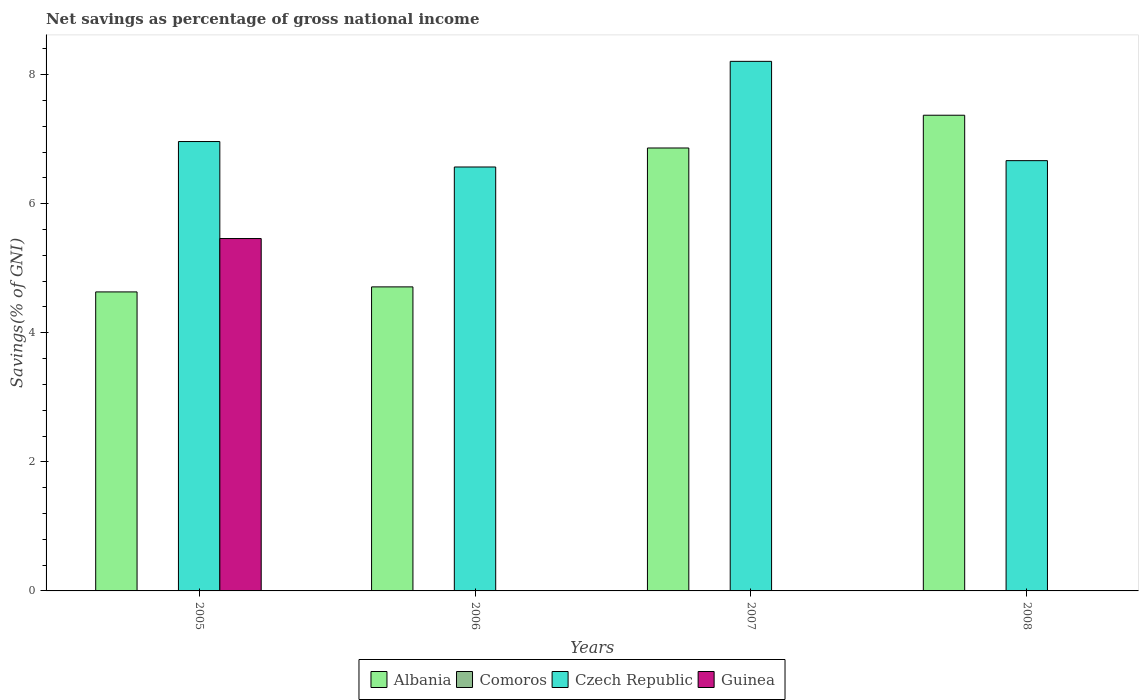Are the number of bars per tick equal to the number of legend labels?
Offer a very short reply. No. How many bars are there on the 4th tick from the left?
Your answer should be very brief. 2. What is the label of the 4th group of bars from the left?
Your answer should be compact. 2008. In how many cases, is the number of bars for a given year not equal to the number of legend labels?
Make the answer very short. 4. What is the total savings in Guinea in 2007?
Provide a succinct answer. 0. Across all years, what is the maximum total savings in Czech Republic?
Provide a succinct answer. 8.21. What is the total total savings in Albania in the graph?
Provide a short and direct response. 23.58. What is the difference between the total savings in Albania in 2005 and that in 2007?
Make the answer very short. -2.23. What is the average total savings in Czech Republic per year?
Your response must be concise. 7.1. In the year 2008, what is the difference between the total savings in Albania and total savings in Czech Republic?
Your response must be concise. 0.7. In how many years, is the total savings in Albania greater than 4 %?
Keep it short and to the point. 4. What is the ratio of the total savings in Albania in 2006 to that in 2007?
Your response must be concise. 0.69. What is the difference between the highest and the second highest total savings in Czech Republic?
Offer a very short reply. 1.24. What is the difference between the highest and the lowest total savings in Albania?
Offer a very short reply. 2.74. In how many years, is the total savings in Czech Republic greater than the average total savings in Czech Republic taken over all years?
Your answer should be very brief. 1. Is the sum of the total savings in Czech Republic in 2007 and 2008 greater than the maximum total savings in Comoros across all years?
Your answer should be very brief. Yes. Is it the case that in every year, the sum of the total savings in Guinea and total savings in Czech Republic is greater than the sum of total savings in Albania and total savings in Comoros?
Your response must be concise. No. How many years are there in the graph?
Give a very brief answer. 4. What is the difference between two consecutive major ticks on the Y-axis?
Provide a short and direct response. 2. Does the graph contain any zero values?
Offer a very short reply. Yes. Does the graph contain grids?
Offer a very short reply. No. Where does the legend appear in the graph?
Ensure brevity in your answer.  Bottom center. How many legend labels are there?
Your response must be concise. 4. What is the title of the graph?
Offer a terse response. Net savings as percentage of gross national income. Does "Iceland" appear as one of the legend labels in the graph?
Provide a succinct answer. No. What is the label or title of the X-axis?
Your answer should be compact. Years. What is the label or title of the Y-axis?
Your answer should be compact. Savings(% of GNI). What is the Savings(% of GNI) of Albania in 2005?
Your answer should be very brief. 4.63. What is the Savings(% of GNI) in Czech Republic in 2005?
Ensure brevity in your answer.  6.96. What is the Savings(% of GNI) of Guinea in 2005?
Your answer should be compact. 5.46. What is the Savings(% of GNI) of Albania in 2006?
Your response must be concise. 4.71. What is the Savings(% of GNI) in Comoros in 2006?
Give a very brief answer. 0. What is the Savings(% of GNI) in Czech Republic in 2006?
Offer a terse response. 6.57. What is the Savings(% of GNI) in Guinea in 2006?
Provide a short and direct response. 0. What is the Savings(% of GNI) of Albania in 2007?
Provide a succinct answer. 6.86. What is the Savings(% of GNI) of Czech Republic in 2007?
Ensure brevity in your answer.  8.21. What is the Savings(% of GNI) in Albania in 2008?
Make the answer very short. 7.37. What is the Savings(% of GNI) of Comoros in 2008?
Offer a very short reply. 0. What is the Savings(% of GNI) in Czech Republic in 2008?
Provide a short and direct response. 6.67. Across all years, what is the maximum Savings(% of GNI) in Albania?
Provide a short and direct response. 7.37. Across all years, what is the maximum Savings(% of GNI) of Czech Republic?
Give a very brief answer. 8.21. Across all years, what is the maximum Savings(% of GNI) in Guinea?
Make the answer very short. 5.46. Across all years, what is the minimum Savings(% of GNI) of Albania?
Give a very brief answer. 4.63. Across all years, what is the minimum Savings(% of GNI) in Czech Republic?
Your answer should be very brief. 6.57. What is the total Savings(% of GNI) of Albania in the graph?
Ensure brevity in your answer.  23.58. What is the total Savings(% of GNI) of Comoros in the graph?
Your response must be concise. 0. What is the total Savings(% of GNI) in Czech Republic in the graph?
Keep it short and to the point. 28.41. What is the total Savings(% of GNI) in Guinea in the graph?
Give a very brief answer. 5.46. What is the difference between the Savings(% of GNI) of Albania in 2005 and that in 2006?
Make the answer very short. -0.08. What is the difference between the Savings(% of GNI) in Czech Republic in 2005 and that in 2006?
Your answer should be very brief. 0.39. What is the difference between the Savings(% of GNI) of Albania in 2005 and that in 2007?
Provide a short and direct response. -2.23. What is the difference between the Savings(% of GNI) in Czech Republic in 2005 and that in 2007?
Provide a succinct answer. -1.24. What is the difference between the Savings(% of GNI) of Albania in 2005 and that in 2008?
Offer a very short reply. -2.74. What is the difference between the Savings(% of GNI) of Czech Republic in 2005 and that in 2008?
Keep it short and to the point. 0.3. What is the difference between the Savings(% of GNI) in Albania in 2006 and that in 2007?
Ensure brevity in your answer.  -2.15. What is the difference between the Savings(% of GNI) of Czech Republic in 2006 and that in 2007?
Give a very brief answer. -1.64. What is the difference between the Savings(% of GNI) of Albania in 2006 and that in 2008?
Provide a succinct answer. -2.66. What is the difference between the Savings(% of GNI) of Czech Republic in 2006 and that in 2008?
Ensure brevity in your answer.  -0.1. What is the difference between the Savings(% of GNI) in Albania in 2007 and that in 2008?
Make the answer very short. -0.51. What is the difference between the Savings(% of GNI) of Czech Republic in 2007 and that in 2008?
Provide a short and direct response. 1.54. What is the difference between the Savings(% of GNI) in Albania in 2005 and the Savings(% of GNI) in Czech Republic in 2006?
Ensure brevity in your answer.  -1.94. What is the difference between the Savings(% of GNI) in Albania in 2005 and the Savings(% of GNI) in Czech Republic in 2007?
Provide a short and direct response. -3.57. What is the difference between the Savings(% of GNI) of Albania in 2005 and the Savings(% of GNI) of Czech Republic in 2008?
Your answer should be very brief. -2.03. What is the difference between the Savings(% of GNI) of Albania in 2006 and the Savings(% of GNI) of Czech Republic in 2007?
Your response must be concise. -3.5. What is the difference between the Savings(% of GNI) in Albania in 2006 and the Savings(% of GNI) in Czech Republic in 2008?
Keep it short and to the point. -1.96. What is the difference between the Savings(% of GNI) in Albania in 2007 and the Savings(% of GNI) in Czech Republic in 2008?
Your answer should be very brief. 0.2. What is the average Savings(% of GNI) in Albania per year?
Your answer should be very brief. 5.9. What is the average Savings(% of GNI) in Czech Republic per year?
Provide a short and direct response. 7.1. What is the average Savings(% of GNI) in Guinea per year?
Make the answer very short. 1.37. In the year 2005, what is the difference between the Savings(% of GNI) of Albania and Savings(% of GNI) of Czech Republic?
Offer a very short reply. -2.33. In the year 2005, what is the difference between the Savings(% of GNI) in Albania and Savings(% of GNI) in Guinea?
Offer a terse response. -0.83. In the year 2005, what is the difference between the Savings(% of GNI) of Czech Republic and Savings(% of GNI) of Guinea?
Your answer should be compact. 1.5. In the year 2006, what is the difference between the Savings(% of GNI) in Albania and Savings(% of GNI) in Czech Republic?
Your answer should be very brief. -1.86. In the year 2007, what is the difference between the Savings(% of GNI) in Albania and Savings(% of GNI) in Czech Republic?
Your answer should be compact. -1.34. In the year 2008, what is the difference between the Savings(% of GNI) in Albania and Savings(% of GNI) in Czech Republic?
Provide a succinct answer. 0.7. What is the ratio of the Savings(% of GNI) of Albania in 2005 to that in 2006?
Your answer should be very brief. 0.98. What is the ratio of the Savings(% of GNI) of Czech Republic in 2005 to that in 2006?
Keep it short and to the point. 1.06. What is the ratio of the Savings(% of GNI) in Albania in 2005 to that in 2007?
Keep it short and to the point. 0.68. What is the ratio of the Savings(% of GNI) in Czech Republic in 2005 to that in 2007?
Your response must be concise. 0.85. What is the ratio of the Savings(% of GNI) in Albania in 2005 to that in 2008?
Your response must be concise. 0.63. What is the ratio of the Savings(% of GNI) in Czech Republic in 2005 to that in 2008?
Your answer should be very brief. 1.04. What is the ratio of the Savings(% of GNI) of Albania in 2006 to that in 2007?
Ensure brevity in your answer.  0.69. What is the ratio of the Savings(% of GNI) in Czech Republic in 2006 to that in 2007?
Your answer should be compact. 0.8. What is the ratio of the Savings(% of GNI) in Albania in 2006 to that in 2008?
Ensure brevity in your answer.  0.64. What is the ratio of the Savings(% of GNI) of Albania in 2007 to that in 2008?
Provide a short and direct response. 0.93. What is the ratio of the Savings(% of GNI) of Czech Republic in 2007 to that in 2008?
Offer a very short reply. 1.23. What is the difference between the highest and the second highest Savings(% of GNI) in Albania?
Offer a very short reply. 0.51. What is the difference between the highest and the second highest Savings(% of GNI) of Czech Republic?
Provide a short and direct response. 1.24. What is the difference between the highest and the lowest Savings(% of GNI) in Albania?
Offer a very short reply. 2.74. What is the difference between the highest and the lowest Savings(% of GNI) in Czech Republic?
Give a very brief answer. 1.64. What is the difference between the highest and the lowest Savings(% of GNI) in Guinea?
Your response must be concise. 5.46. 